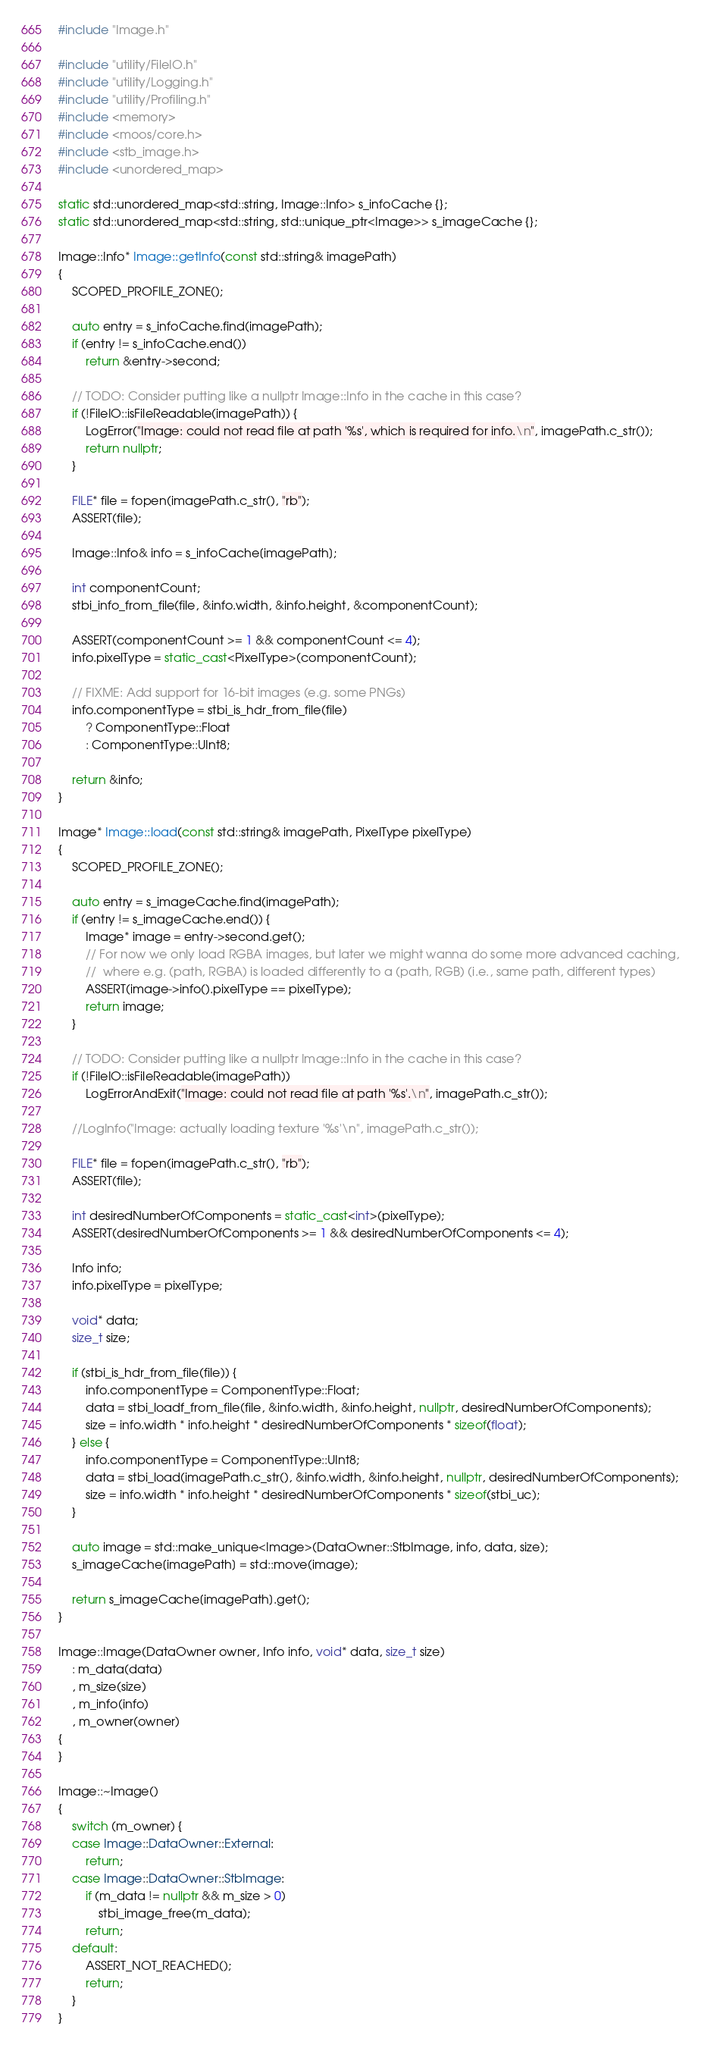<code> <loc_0><loc_0><loc_500><loc_500><_C++_>#include "Image.h"

#include "utility/FileIO.h"
#include "utility/Logging.h"
#include "utility/Profiling.h"
#include <memory>
#include <moos/core.h>
#include <stb_image.h>
#include <unordered_map>

static std::unordered_map<std::string, Image::Info> s_infoCache {};
static std::unordered_map<std::string, std::unique_ptr<Image>> s_imageCache {};

Image::Info* Image::getInfo(const std::string& imagePath)
{
    SCOPED_PROFILE_ZONE();

    auto entry = s_infoCache.find(imagePath);
    if (entry != s_infoCache.end())
        return &entry->second;

    // TODO: Consider putting like a nullptr Image::Info in the cache in this case?
    if (!FileIO::isFileReadable(imagePath)) {
        LogError("Image: could not read file at path '%s', which is required for info.\n", imagePath.c_str());
        return nullptr;
    }

    FILE* file = fopen(imagePath.c_str(), "rb");
    ASSERT(file);

    Image::Info& info = s_infoCache[imagePath];

    int componentCount;
    stbi_info_from_file(file, &info.width, &info.height, &componentCount);

    ASSERT(componentCount >= 1 && componentCount <= 4);
    info.pixelType = static_cast<PixelType>(componentCount);

    // FIXME: Add support for 16-bit images (e.g. some PNGs)
    info.componentType = stbi_is_hdr_from_file(file)
        ? ComponentType::Float
        : ComponentType::UInt8;

    return &info;
}

Image* Image::load(const std::string& imagePath, PixelType pixelType)
{
    SCOPED_PROFILE_ZONE();

    auto entry = s_imageCache.find(imagePath);
    if (entry != s_imageCache.end()) {
        Image* image = entry->second.get();
        // For now we only load RGBA images, but later we might wanna do some more advanced caching,
        //  where e.g. (path, RGBA) is loaded differently to a (path, RGB) (i.e., same path, different types)
        ASSERT(image->info().pixelType == pixelType);
        return image;
    }

    // TODO: Consider putting like a nullptr Image::Info in the cache in this case?
    if (!FileIO::isFileReadable(imagePath))
        LogErrorAndExit("Image: could not read file at path '%s'.\n", imagePath.c_str());

    //LogInfo("Image: actually loading texture '%s'\n", imagePath.c_str());

    FILE* file = fopen(imagePath.c_str(), "rb");
    ASSERT(file);

    int desiredNumberOfComponents = static_cast<int>(pixelType);
    ASSERT(desiredNumberOfComponents >= 1 && desiredNumberOfComponents <= 4);

    Info info;
    info.pixelType = pixelType;

    void* data;
    size_t size;

    if (stbi_is_hdr_from_file(file)) {
        info.componentType = ComponentType::Float;
        data = stbi_loadf_from_file(file, &info.width, &info.height, nullptr, desiredNumberOfComponents);
        size = info.width * info.height * desiredNumberOfComponents * sizeof(float);
    } else {
        info.componentType = ComponentType::UInt8;
        data = stbi_load(imagePath.c_str(), &info.width, &info.height, nullptr, desiredNumberOfComponents);
        size = info.width * info.height * desiredNumberOfComponents * sizeof(stbi_uc);
    }

    auto image = std::make_unique<Image>(DataOwner::StbImage, info, data, size);
    s_imageCache[imagePath] = std::move(image);

    return s_imageCache[imagePath].get();
}

Image::Image(DataOwner owner, Info info, void* data, size_t size)
    : m_data(data)
    , m_size(size)
    , m_info(info)
    , m_owner(owner)
{
}

Image::~Image()
{
    switch (m_owner) {
    case Image::DataOwner::External:
        return;
    case Image::DataOwner::StbImage:
        if (m_data != nullptr && m_size > 0)
            stbi_image_free(m_data);
        return;
    default:
        ASSERT_NOT_REACHED();
        return;
    }
}
</code> 